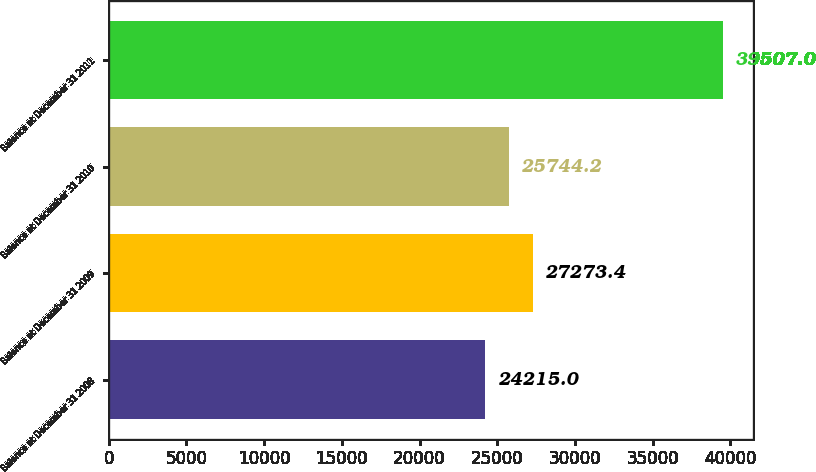Convert chart to OTSL. <chart><loc_0><loc_0><loc_500><loc_500><bar_chart><fcel>Balance at December 31 2008<fcel>Balance at December 31 2009<fcel>Balance at December 31 2010<fcel>Balance at December 31 2011<nl><fcel>24215<fcel>27273.4<fcel>25744.2<fcel>39507<nl></chart> 